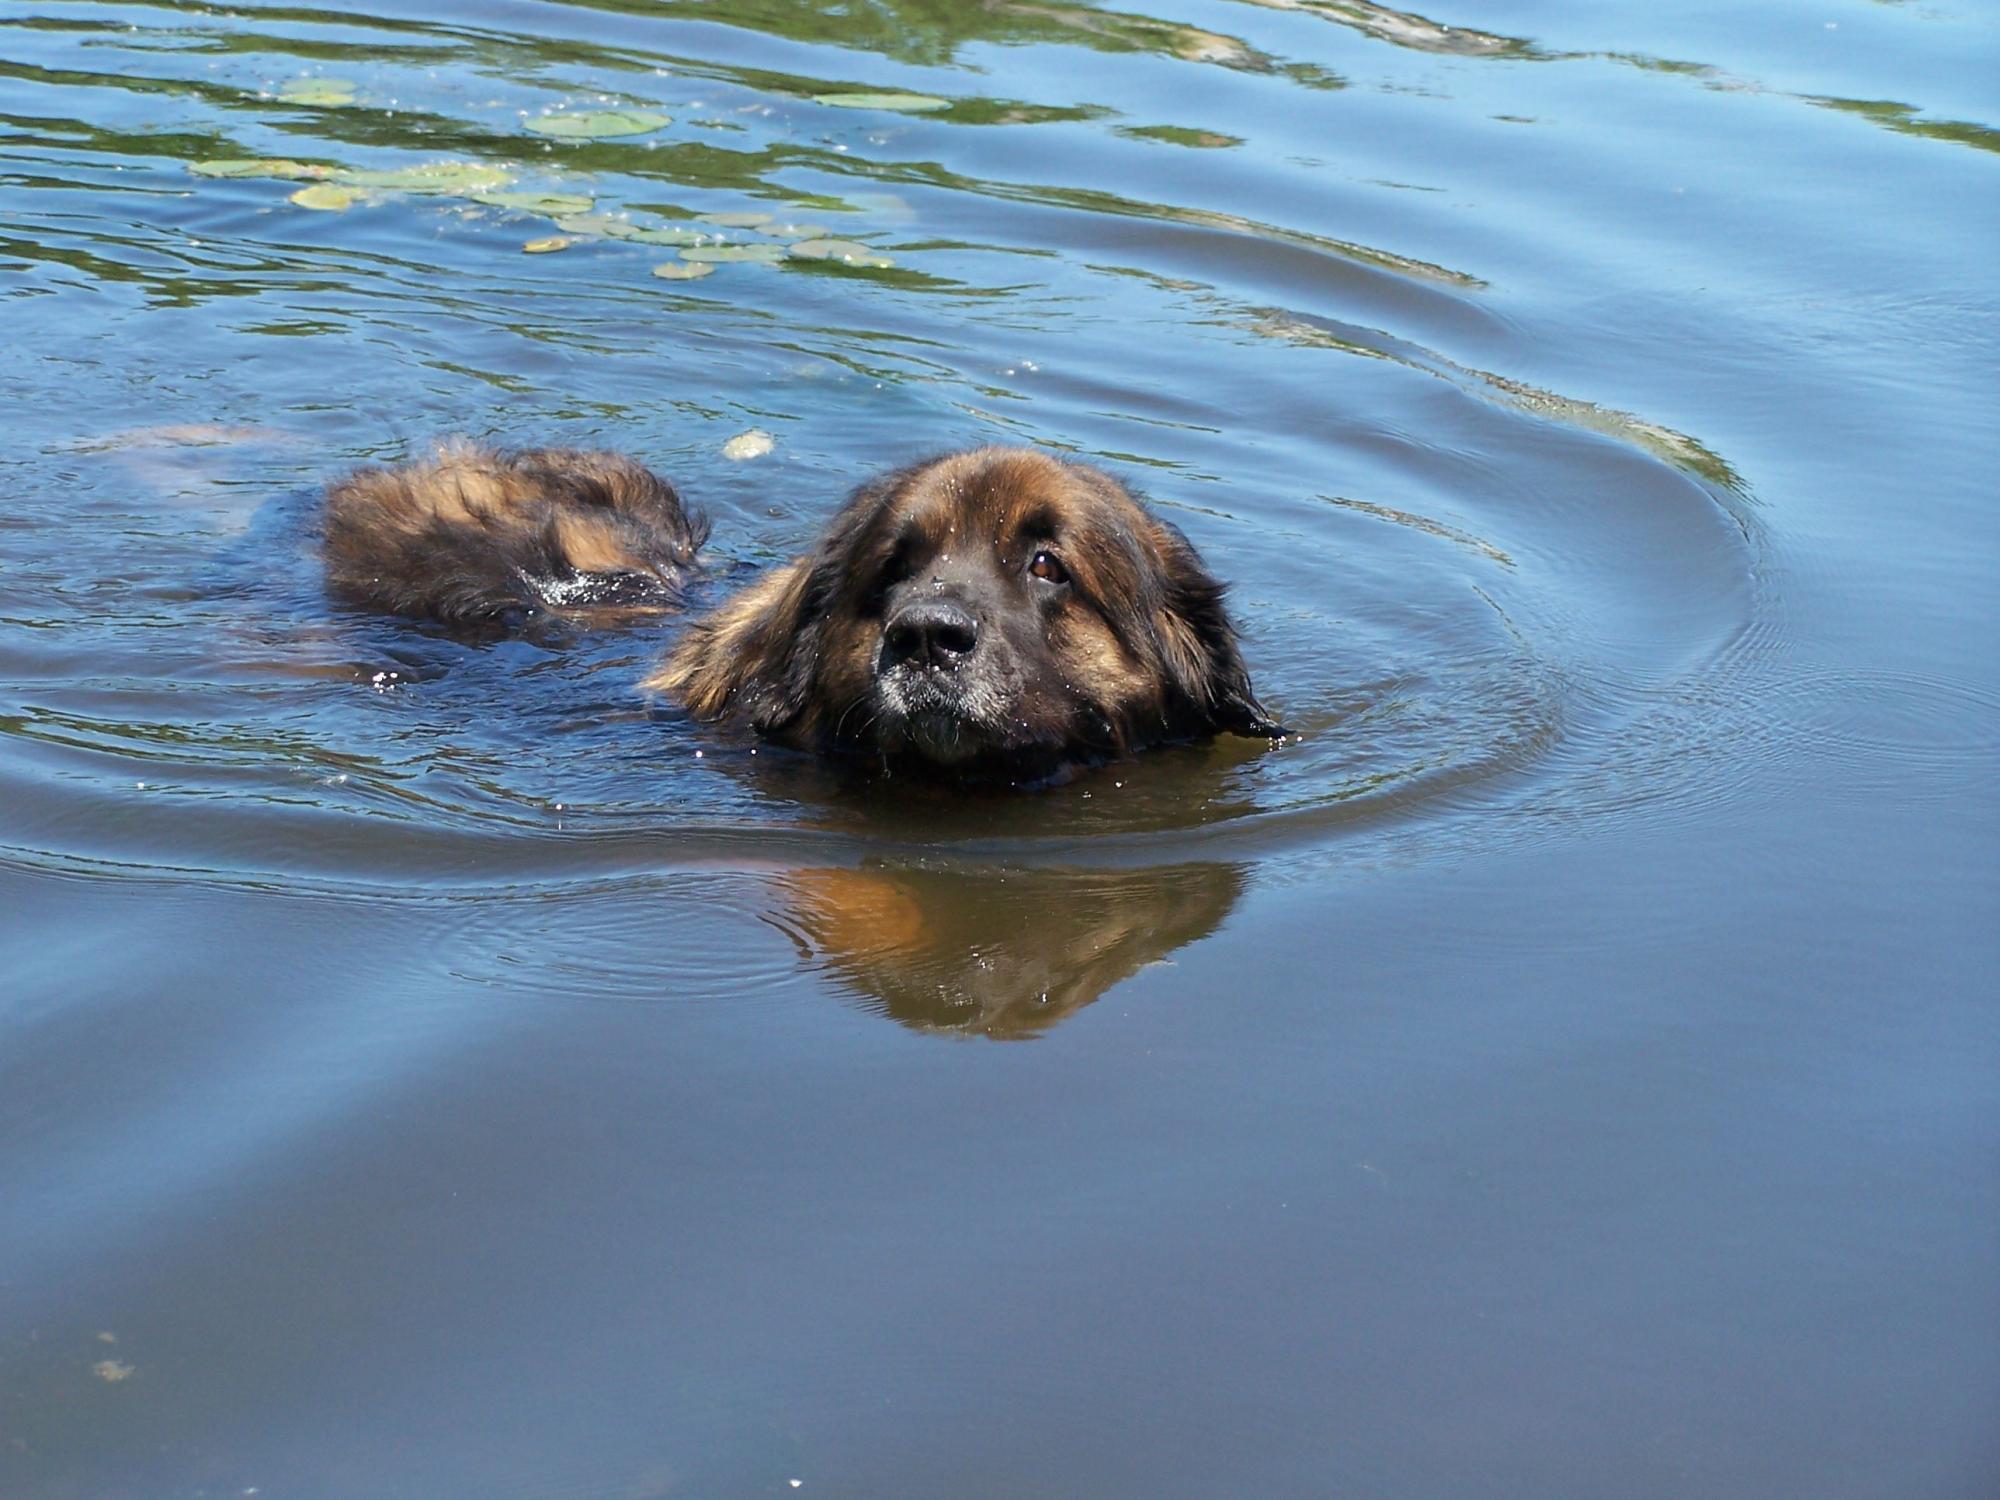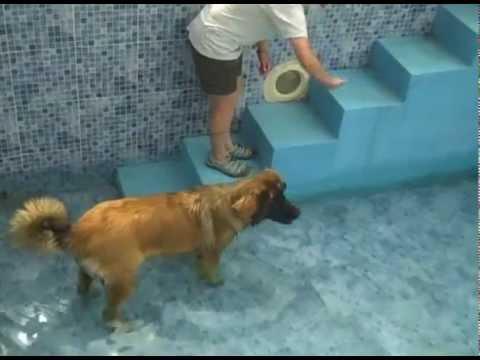The first image is the image on the left, the second image is the image on the right. Given the left and right images, does the statement "An image shows one forward-facing dog swimming in a natural body of water." hold true? Answer yes or no. Yes. 